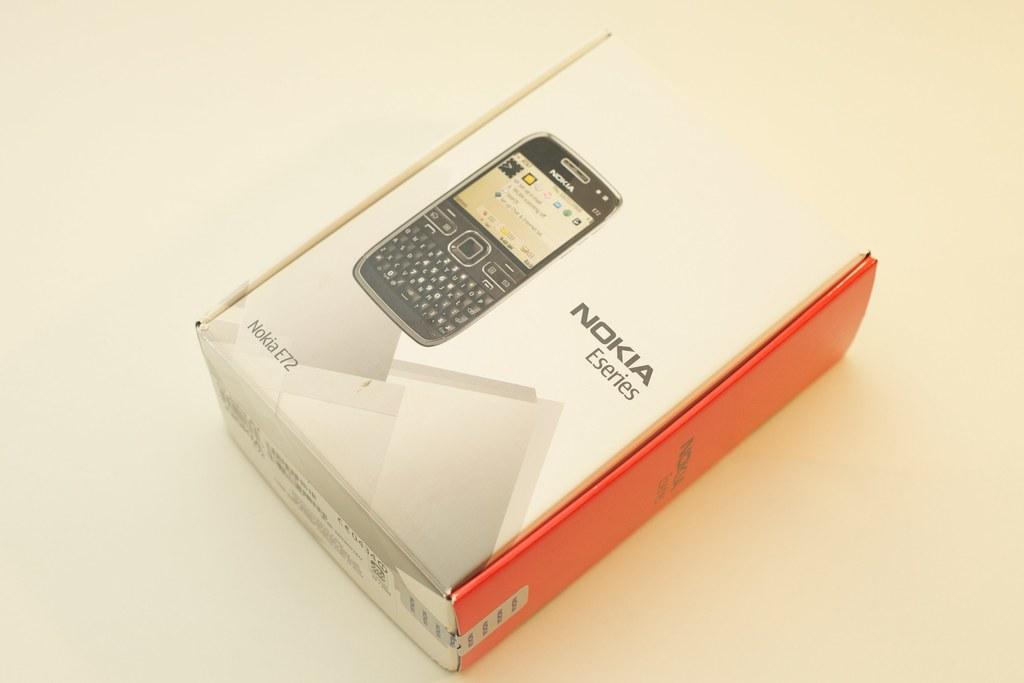What brand is this device?
Ensure brevity in your answer.  Nokia. 